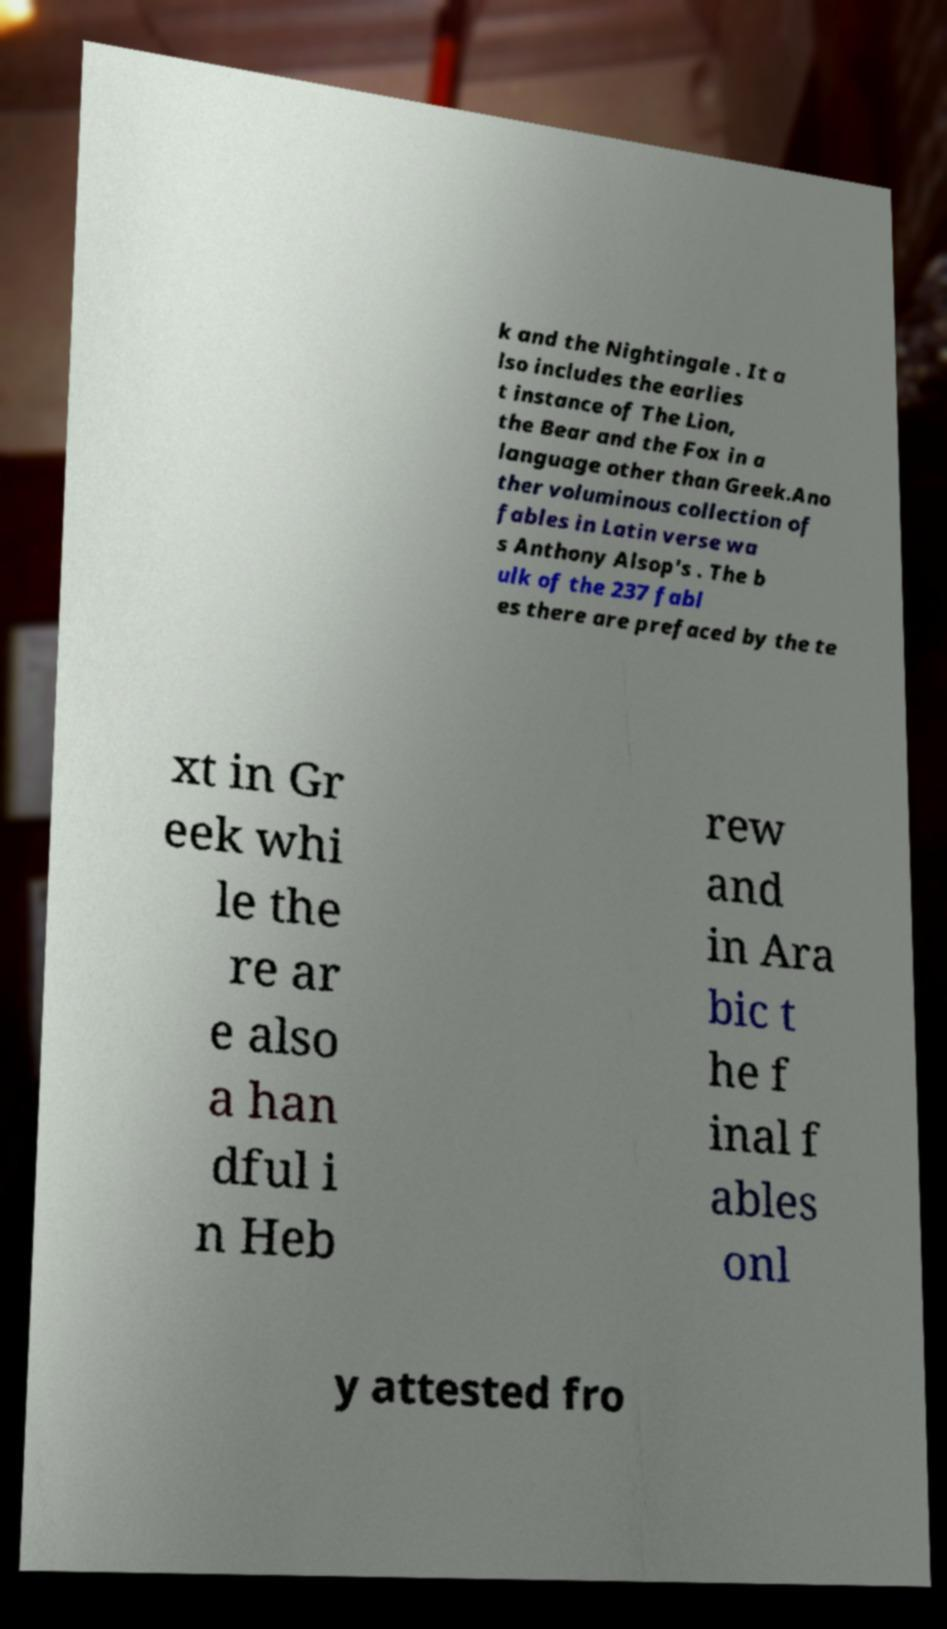For documentation purposes, I need the text within this image transcribed. Could you provide that? k and the Nightingale . It a lso includes the earlies t instance of The Lion, the Bear and the Fox in a language other than Greek.Ano ther voluminous collection of fables in Latin verse wa s Anthony Alsop's . The b ulk of the 237 fabl es there are prefaced by the te xt in Gr eek whi le the re ar e also a han dful i n Heb rew and in Ara bic t he f inal f ables onl y attested fro 